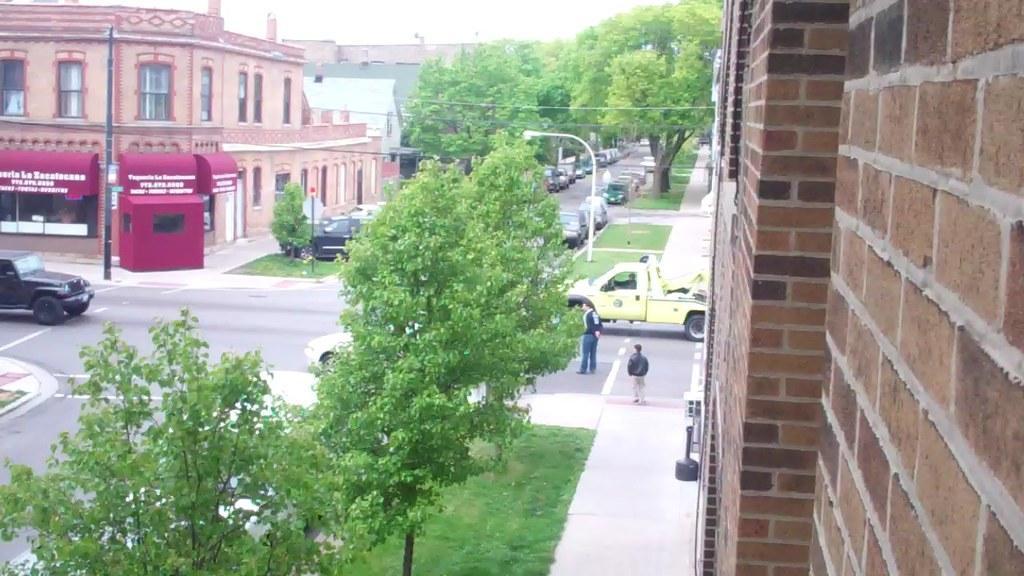Could you give a brief overview of what you see in this image? In this image I can see the road. On the road I can see the vehicles and few people standing. To the side of the road I can see the poles and many trees. To the right I can see the brown color brick wall. In the background I can see buildings and the sky. 